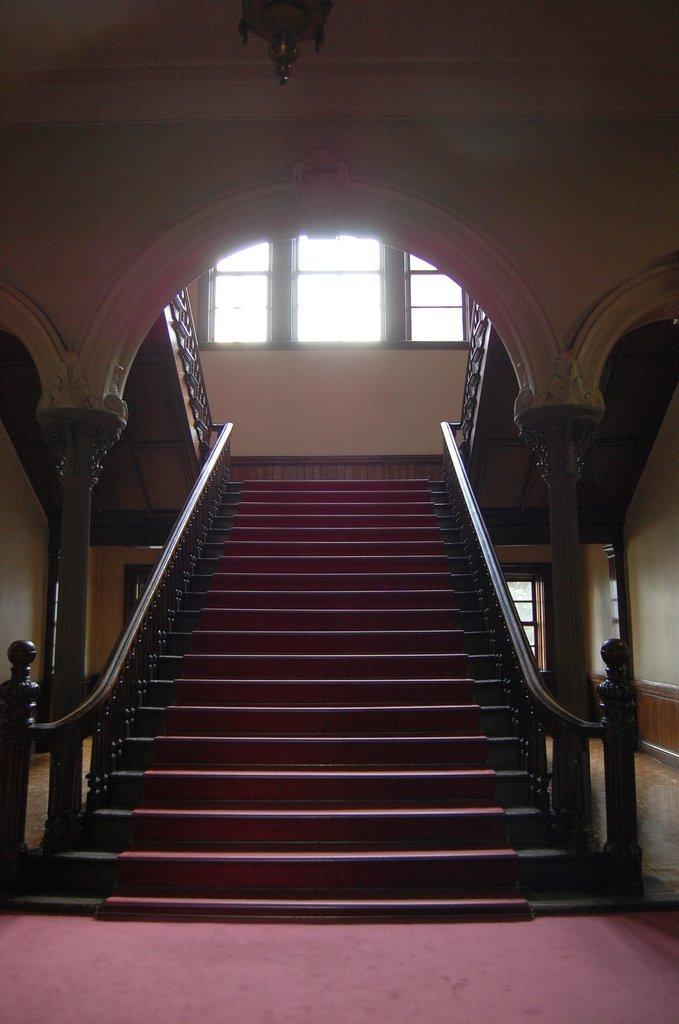Could you give a brief overview of what you see in this image? This picture describes about inside view of a building, in this we can find steps and windows. 